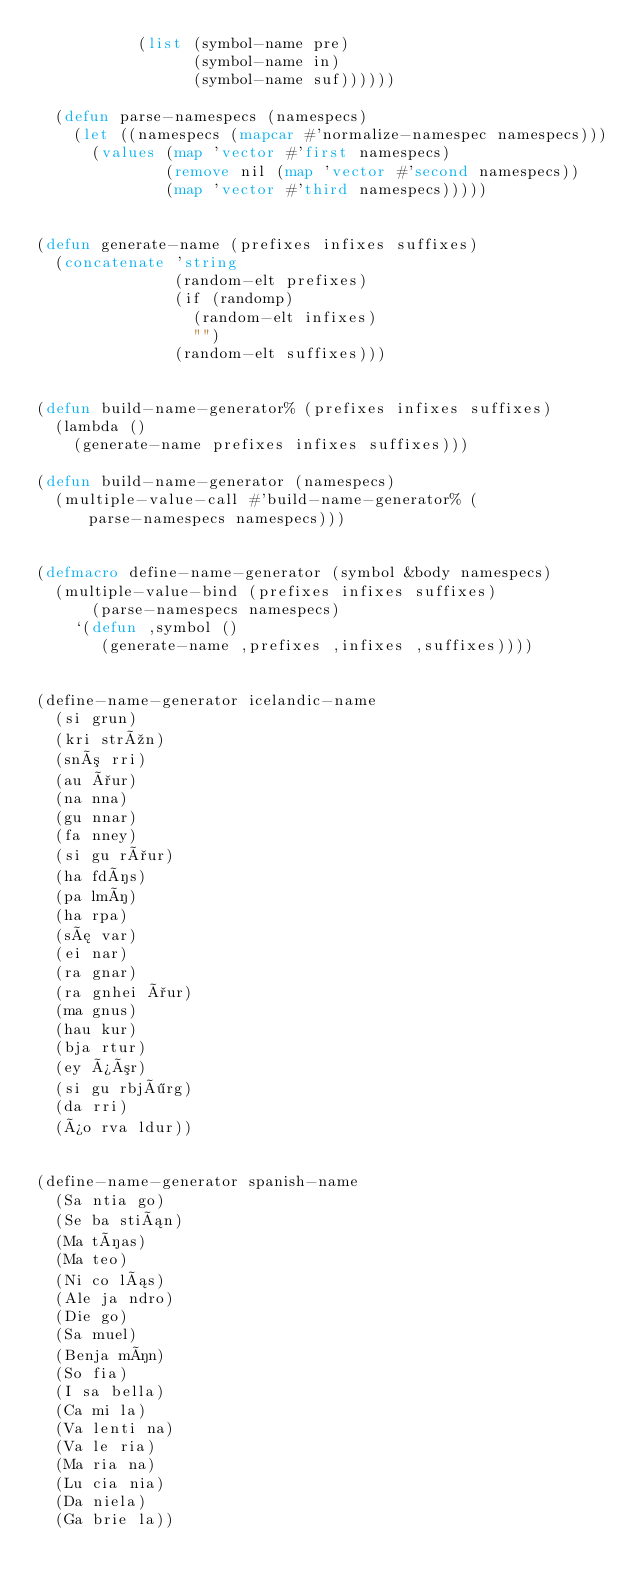Convert code to text. <code><loc_0><loc_0><loc_500><loc_500><_Lisp_>           (list (symbol-name pre)
                 (symbol-name in)
                 (symbol-name suf))))))

  (defun parse-namespecs (namespecs)
    (let ((namespecs (mapcar #'normalize-namespec namespecs)))
      (values (map 'vector #'first namespecs)
              (remove nil (map 'vector #'second namespecs))
              (map 'vector #'third namespecs)))))


(defun generate-name (prefixes infixes suffixes)
  (concatenate 'string
               (random-elt prefixes)
               (if (randomp)
                 (random-elt infixes)
                 "")
               (random-elt suffixes)))


(defun build-name-generator% (prefixes infixes suffixes)
  (lambda ()
    (generate-name prefixes infixes suffixes)))

(defun build-name-generator (namespecs)
  (multiple-value-call #'build-name-generator% (parse-namespecs namespecs)))


(defmacro define-name-generator (symbol &body namespecs)
  (multiple-value-bind (prefixes infixes suffixes)
      (parse-namespecs namespecs)
    `(defun ,symbol ()
       (generate-name ,prefixes ,infixes ,suffixes))))


(define-name-generator icelandic-name
  (si grun)
  (kri strún)
  (snó rri)
  (au ður)
  (na nna)
  (gu nnar)
  (fa nney)
  (si gu rður)
  (ha fdís)
  (pa lmí)
  (ha rpa)
  (sæ var)
  (ei nar)
  (ra gnar)
  (ra gnhei ður)
  (ma gnus)
  (hau kur)
  (bja rtur)
  (ey þór)
  (si gu rbjörg)
  (da rri)
  (þo rva ldur))


(define-name-generator spanish-name
  (Sa ntia go)
  (Se ba stián)
  (Ma tías)
  (Ma teo)
  (Ni co lás)
  (Ale ja ndro)
  (Die go)
  (Sa muel)
  (Benja mín)
  (So fia)
  (I sa bella)
  (Ca mi la)
  (Va lenti na)
  (Va le ria)
  (Ma ria na)
  (Lu cia nia)
  (Da niela)
  (Ga brie la))

</code> 